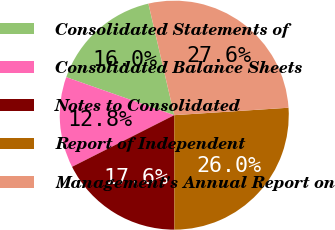<chart> <loc_0><loc_0><loc_500><loc_500><pie_chart><fcel>Consolidated Statements of<fcel>Consolidated Balance Sheets<fcel>Notes to Consolidated<fcel>Report of Independent<fcel>Management's Annual Report on<nl><fcel>15.99%<fcel>12.83%<fcel>17.57%<fcel>26.01%<fcel>27.59%<nl></chart> 